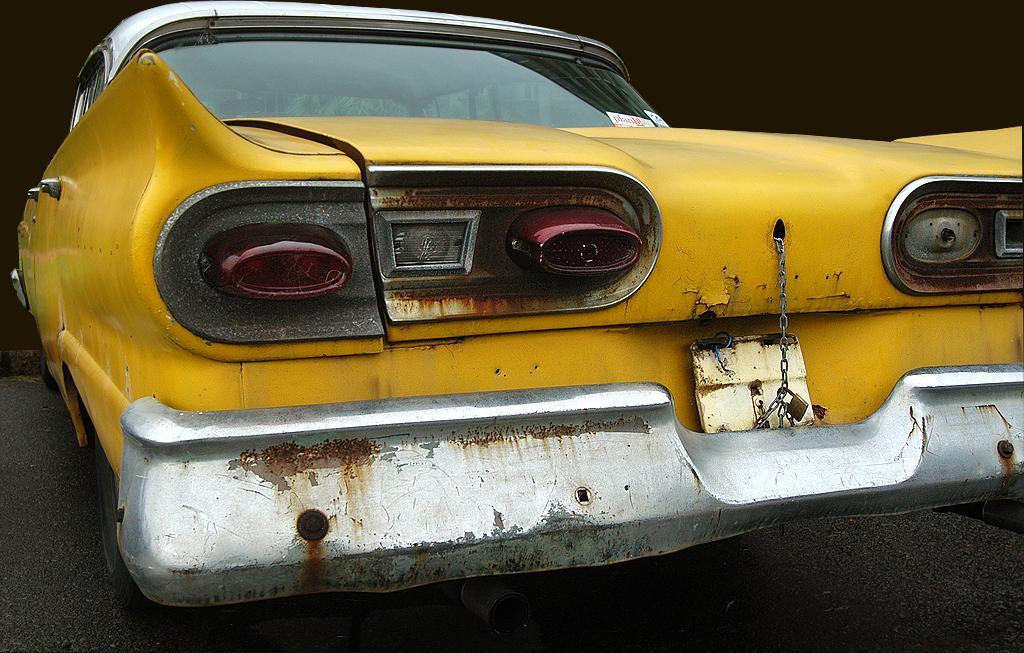Can you describe this image briefly? In this image I can see the car in yellow and white color and I can see the dark background. 